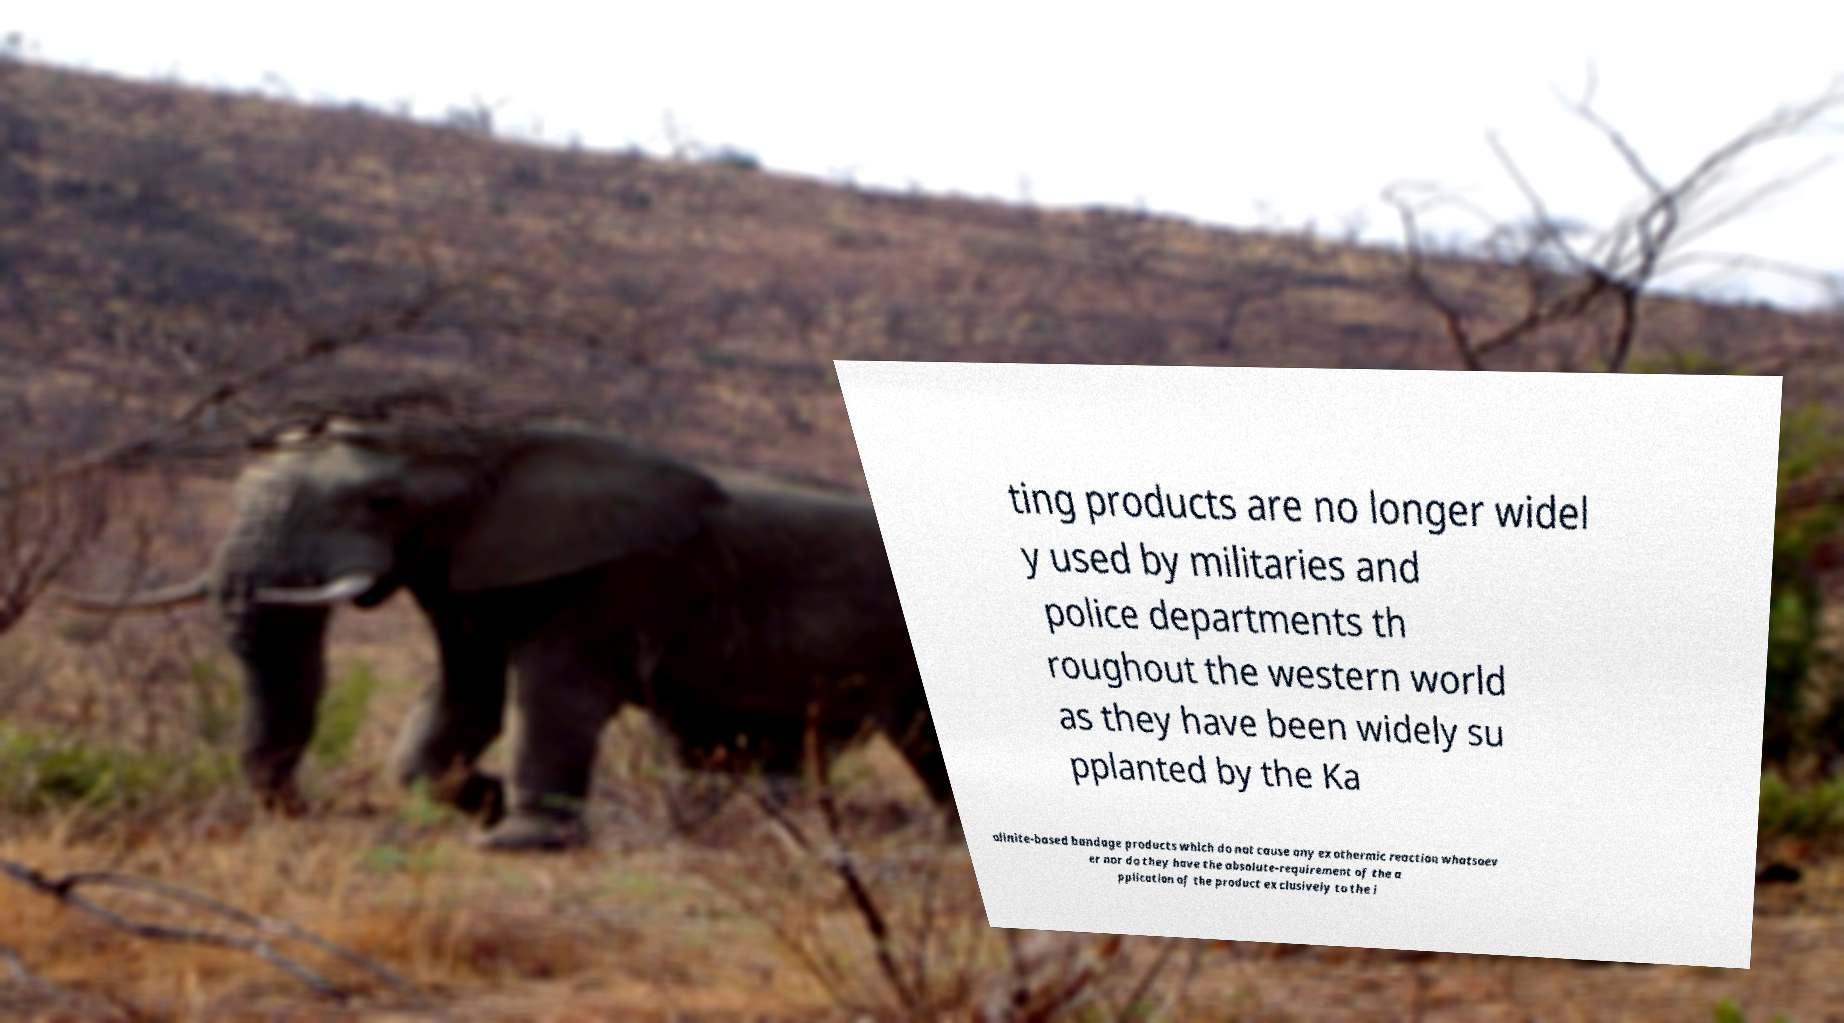For documentation purposes, I need the text within this image transcribed. Could you provide that? ting products are no longer widel y used by militaries and police departments th roughout the western world as they have been widely su pplanted by the Ka olinite-based bandage products which do not cause any exothermic reaction whatsoev er nor do they have the absolute-requirement of the a pplication of the product exclusively to the i 